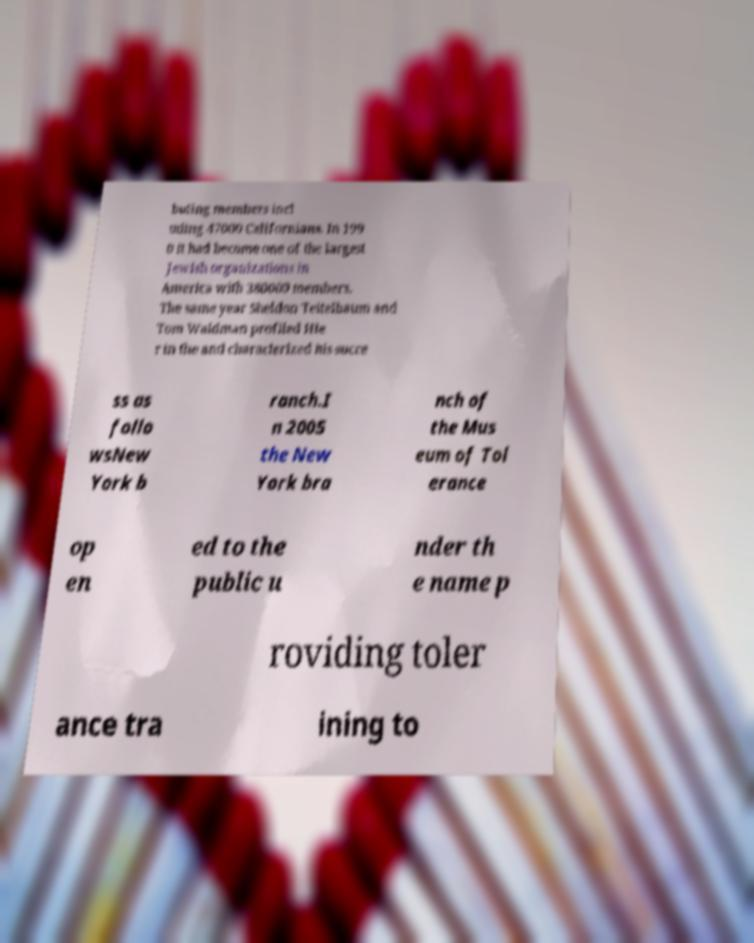What messages or text are displayed in this image? I need them in a readable, typed format. buting members incl uding 47000 Californians. In 199 0 it had become one of the largest Jewish organizations in America with 380000 members. The same year Sheldon Teitelbaum and Tom Waldman profiled Hie r in the and characterized his succe ss as follo wsNew York b ranch.I n 2005 the New York bra nch of the Mus eum of Tol erance op en ed to the public u nder th e name p roviding toler ance tra ining to 